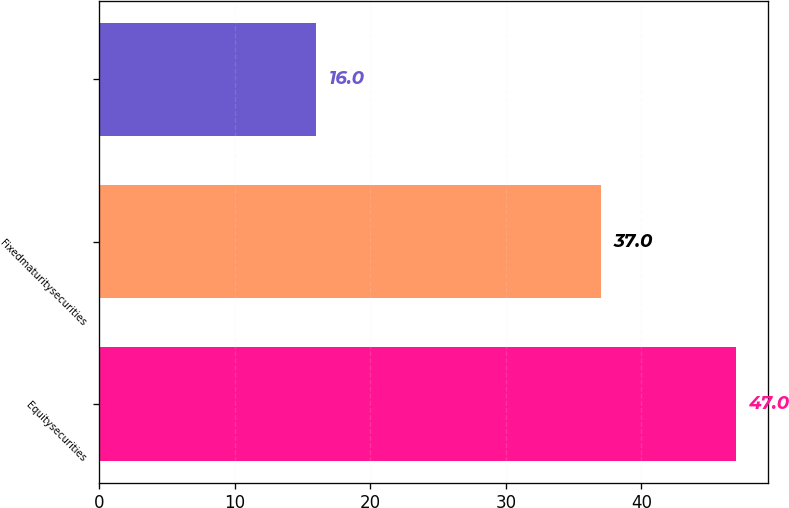Convert chart to OTSL. <chart><loc_0><loc_0><loc_500><loc_500><bar_chart><fcel>Equitysecurities<fcel>Fixedmaturitysecurities<fcel>Unnamed: 2<nl><fcel>47<fcel>37<fcel>16<nl></chart> 